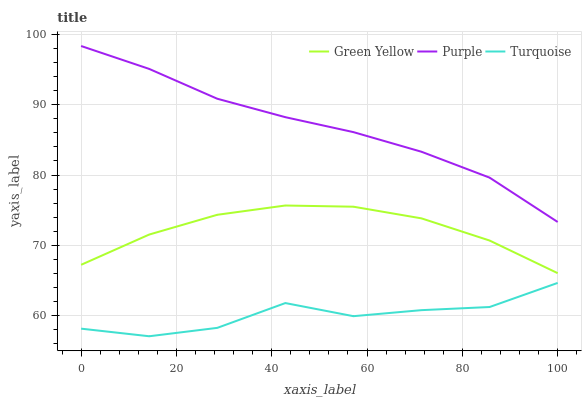Does Turquoise have the minimum area under the curve?
Answer yes or no. Yes. Does Purple have the maximum area under the curve?
Answer yes or no. Yes. Does Green Yellow have the minimum area under the curve?
Answer yes or no. No. Does Green Yellow have the maximum area under the curve?
Answer yes or no. No. Is Purple the smoothest?
Answer yes or no. Yes. Is Turquoise the roughest?
Answer yes or no. Yes. Is Green Yellow the smoothest?
Answer yes or no. No. Is Green Yellow the roughest?
Answer yes or no. No. Does Green Yellow have the lowest value?
Answer yes or no. No. Does Purple have the highest value?
Answer yes or no. Yes. Does Green Yellow have the highest value?
Answer yes or no. No. Is Turquoise less than Purple?
Answer yes or no. Yes. Is Purple greater than Turquoise?
Answer yes or no. Yes. Does Turquoise intersect Purple?
Answer yes or no. No. 